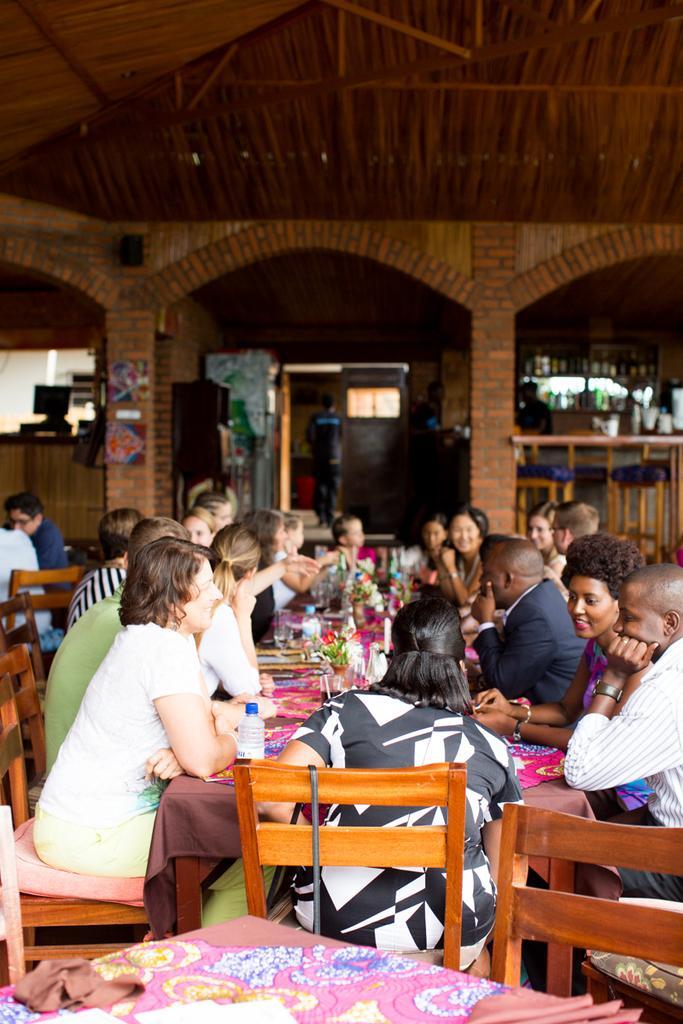In one or two sentences, can you explain what this image depicts? In this picture we can see group of people consisting of man and woman sitting on chair and in front of them there is table and on table we can see vase with flowers, bottle, glass and in background we can see monitor, person standing, refrigerator, window, fence. 